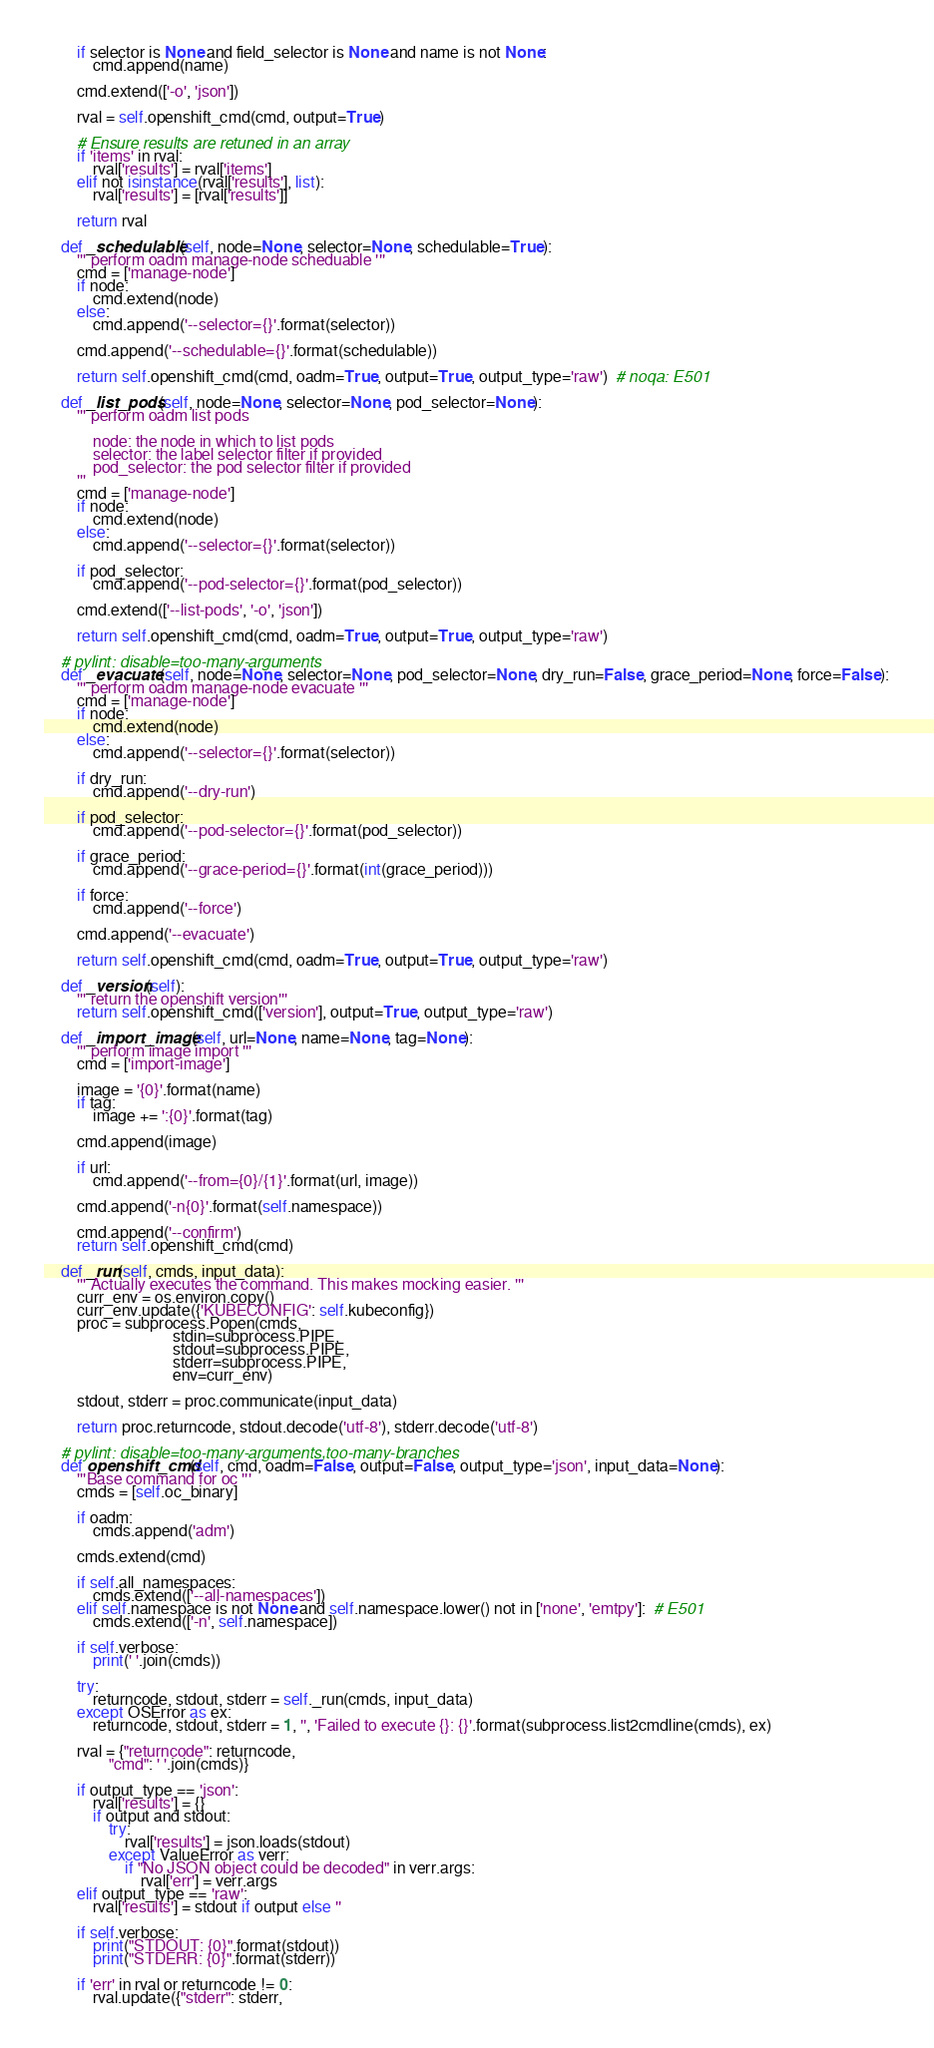<code> <loc_0><loc_0><loc_500><loc_500><_Python_>        if selector is None and field_selector is None and name is not None:
            cmd.append(name)

        cmd.extend(['-o', 'json'])

        rval = self.openshift_cmd(cmd, output=True)

        # Ensure results are retuned in an array
        if 'items' in rval:
            rval['results'] = rval['items']
        elif not isinstance(rval['results'], list):
            rval['results'] = [rval['results']]

        return rval

    def _schedulable(self, node=None, selector=None, schedulable=True):
        ''' perform oadm manage-node scheduable '''
        cmd = ['manage-node']
        if node:
            cmd.extend(node)
        else:
            cmd.append('--selector={}'.format(selector))

        cmd.append('--schedulable={}'.format(schedulable))

        return self.openshift_cmd(cmd, oadm=True, output=True, output_type='raw')  # noqa: E501

    def _list_pods(self, node=None, selector=None, pod_selector=None):
        ''' perform oadm list pods

            node: the node in which to list pods
            selector: the label selector filter if provided
            pod_selector: the pod selector filter if provided
        '''
        cmd = ['manage-node']
        if node:
            cmd.extend(node)
        else:
            cmd.append('--selector={}'.format(selector))

        if pod_selector:
            cmd.append('--pod-selector={}'.format(pod_selector))

        cmd.extend(['--list-pods', '-o', 'json'])

        return self.openshift_cmd(cmd, oadm=True, output=True, output_type='raw')

    # pylint: disable=too-many-arguments
    def _evacuate(self, node=None, selector=None, pod_selector=None, dry_run=False, grace_period=None, force=False):
        ''' perform oadm manage-node evacuate '''
        cmd = ['manage-node']
        if node:
            cmd.extend(node)
        else:
            cmd.append('--selector={}'.format(selector))

        if dry_run:
            cmd.append('--dry-run')

        if pod_selector:
            cmd.append('--pod-selector={}'.format(pod_selector))

        if grace_period:
            cmd.append('--grace-period={}'.format(int(grace_period)))

        if force:
            cmd.append('--force')

        cmd.append('--evacuate')

        return self.openshift_cmd(cmd, oadm=True, output=True, output_type='raw')

    def _version(self):
        ''' return the openshift version'''
        return self.openshift_cmd(['version'], output=True, output_type='raw')

    def _import_image(self, url=None, name=None, tag=None):
        ''' perform image import '''
        cmd = ['import-image']

        image = '{0}'.format(name)
        if tag:
            image += ':{0}'.format(tag)

        cmd.append(image)

        if url:
            cmd.append('--from={0}/{1}'.format(url, image))

        cmd.append('-n{0}'.format(self.namespace))

        cmd.append('--confirm')
        return self.openshift_cmd(cmd)

    def _run(self, cmds, input_data):
        ''' Actually executes the command. This makes mocking easier. '''
        curr_env = os.environ.copy()
        curr_env.update({'KUBECONFIG': self.kubeconfig})
        proc = subprocess.Popen(cmds,
                                stdin=subprocess.PIPE,
                                stdout=subprocess.PIPE,
                                stderr=subprocess.PIPE,
                                env=curr_env)

        stdout, stderr = proc.communicate(input_data)

        return proc.returncode, stdout.decode('utf-8'), stderr.decode('utf-8')

    # pylint: disable=too-many-arguments,too-many-branches
    def openshift_cmd(self, cmd, oadm=False, output=False, output_type='json', input_data=None):
        '''Base command for oc '''
        cmds = [self.oc_binary]

        if oadm:
            cmds.append('adm')

        cmds.extend(cmd)

        if self.all_namespaces:
            cmds.extend(['--all-namespaces'])
        elif self.namespace is not None and self.namespace.lower() not in ['none', 'emtpy']:  # E501
            cmds.extend(['-n', self.namespace])

        if self.verbose:
            print(' '.join(cmds))

        try:
            returncode, stdout, stderr = self._run(cmds, input_data)
        except OSError as ex:
            returncode, stdout, stderr = 1, '', 'Failed to execute {}: {}'.format(subprocess.list2cmdline(cmds), ex)

        rval = {"returncode": returncode,
                "cmd": ' '.join(cmds)}

        if output_type == 'json':
            rval['results'] = {}
            if output and stdout:
                try:
                    rval['results'] = json.loads(stdout)
                except ValueError as verr:
                    if "No JSON object could be decoded" in verr.args:
                        rval['err'] = verr.args
        elif output_type == 'raw':
            rval['results'] = stdout if output else ''

        if self.verbose:
            print("STDOUT: {0}".format(stdout))
            print("STDERR: {0}".format(stderr))

        if 'err' in rval or returncode != 0:
            rval.update({"stderr": stderr,</code> 